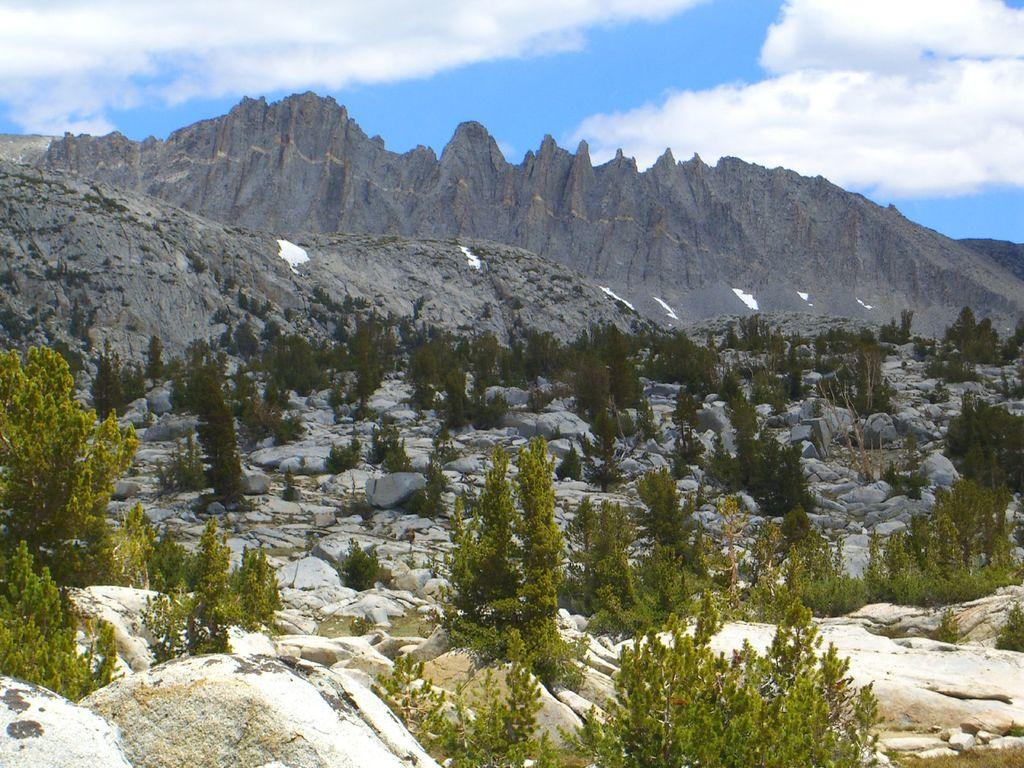What type of natural elements can be seen in the image? There are trees and rocks visible in the image. What type of landscape is depicted in the background of the image? There are mountains in the background of the image. What is visible at the top of the image? There are clouds visible at the top of the image. How many stars can be seen in the image? There are no stars visible in the image. What type of waste is present in the image? There is no waste present in the image. 